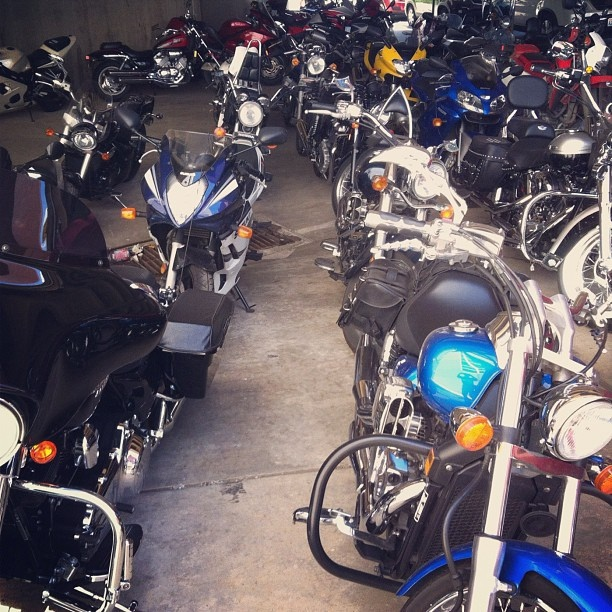Describe the objects in this image and their specific colors. I can see motorcycle in black, gray, ivory, and darkgray tones, motorcycle in black, gray, and ivory tones, motorcycle in black, gray, ivory, and darkgray tones, motorcycle in black, gray, navy, and lightgray tones, and motorcycle in black, gray, lightgray, and darkgray tones in this image. 